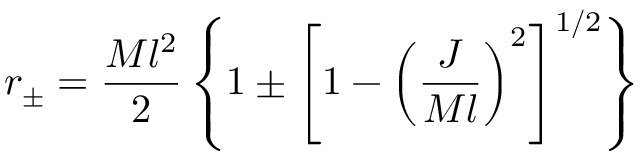Convert formula to latex. <formula><loc_0><loc_0><loc_500><loc_500>r _ { \pm } = { \frac { M l ^ { 2 } } { 2 } } \left \{ 1 \pm \left [ 1 - \left ( { \frac { J } { M l } } \right ) ^ { 2 } \right ] ^ { 1 / 2 } \right \}</formula> 